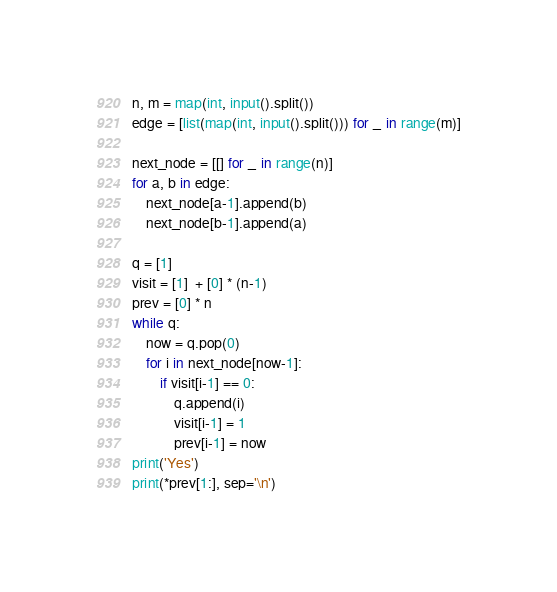Convert code to text. <code><loc_0><loc_0><loc_500><loc_500><_Python_>n, m = map(int, input().split())
edge = [list(map(int, input().split())) for _ in range(m)]

next_node = [[] for _ in range(n)]
for a, b in edge:
    next_node[a-1].append(b)
    next_node[b-1].append(a)

q = [1]
visit = [1]  + [0] * (n-1)
prev = [0] * n
while q:
    now = q.pop(0)
    for i in next_node[now-1]:
        if visit[i-1] == 0:
            q.append(i)
            visit[i-1] = 1
            prev[i-1] = now
print('Yes')
print(*prev[1:], sep='\n')</code> 